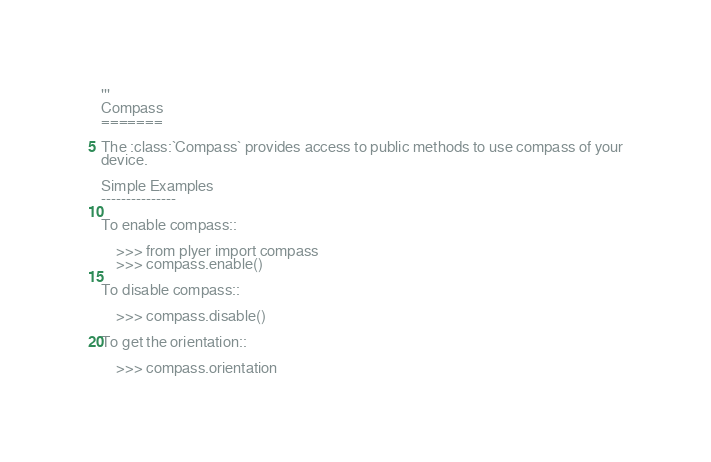<code> <loc_0><loc_0><loc_500><loc_500><_Python_>'''
Compass
=======

The :class:`Compass` provides access to public methods to use compass of your
device.

Simple Examples
---------------

To enable compass::

    >>> from plyer import compass
    >>> compass.enable()

To disable compass::

    >>> compass.disable()

To get the orientation::

    >>> compass.orientation</code> 